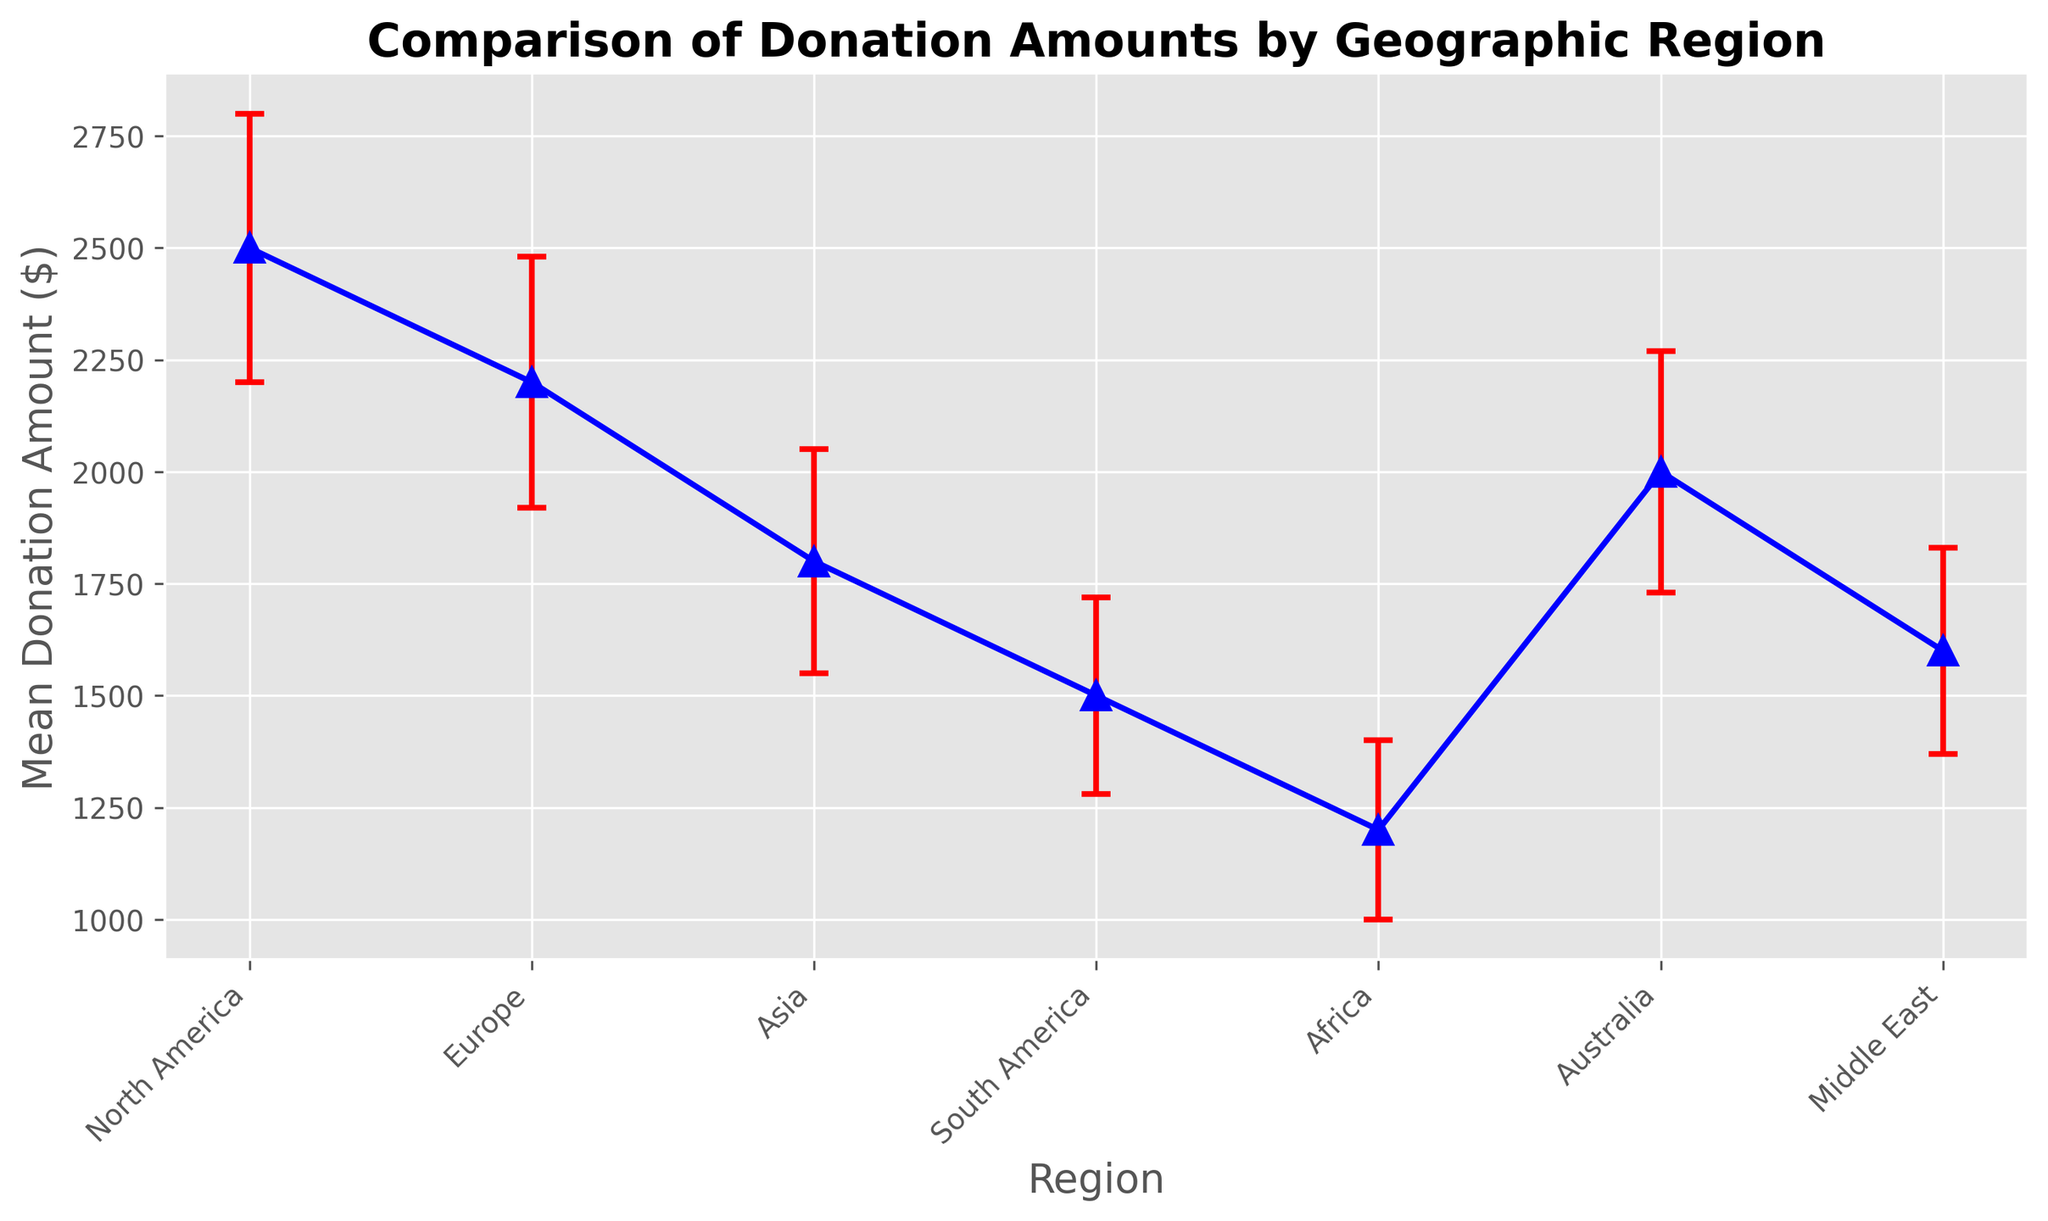Which region has the highest mean donation amount? North America has the highest mean donation amount. The chart shows different regions along with their mean donation values, and North America's mean donation amount stands out as the highest at $2500.
Answer: North America Which region has the lowest mean donation amount? Africa has the lowest mean donation amount. By observing the points on the chart, Africa's mean donation amount is at the lowest value of $1200.
Answer: Africa What is the range of standard deviations in the donations across the regions? The range is calculated by finding the difference between the highest and lowest standard deviations. The highest standard deviation is 300 (North America), and the lowest is 200 (Africa). So, the range is 300 - 200 = 100.
Answer: 100 How does the mean donation amount in Europe compare to that in Australia? Europe and Australia have mean donation amounts of $2200 and $2000, respectively. Europe’s mean donation is $200 higher than Australia’s.
Answer: Europe > Australia by $200 What is the average mean donation amount across all regions? Add up all the mean donation amounts and divide by the number of regions. The sum is 2500 + 2200 + 1800 + 1500 + 1200 + 2000 + 1600 = 12800. There are 7 regions, so the average is 12800 / 7 ≈ 1828.57.
Answer: 1828.57 Which region has the second highest standard deviation in donation amounts? The chart shows the standard deviations, and sorting them in descending order, we see that North America has the highest (300) and Europe has the second highest (280).
Answer: Europe What is the total sum of the mean donation amounts for North America and Asia? Add the mean donations of North America ($2500) and Asia ($1800). The sum is 2500 + 1800 = 4300.
Answer: 4300 How do the standard deviations of donations in South America and Africa compare? South America's standard deviation is 220, while Africa's is 200. South America has a larger standard deviation by 20 units.
Answer: South America > Africa by 20 